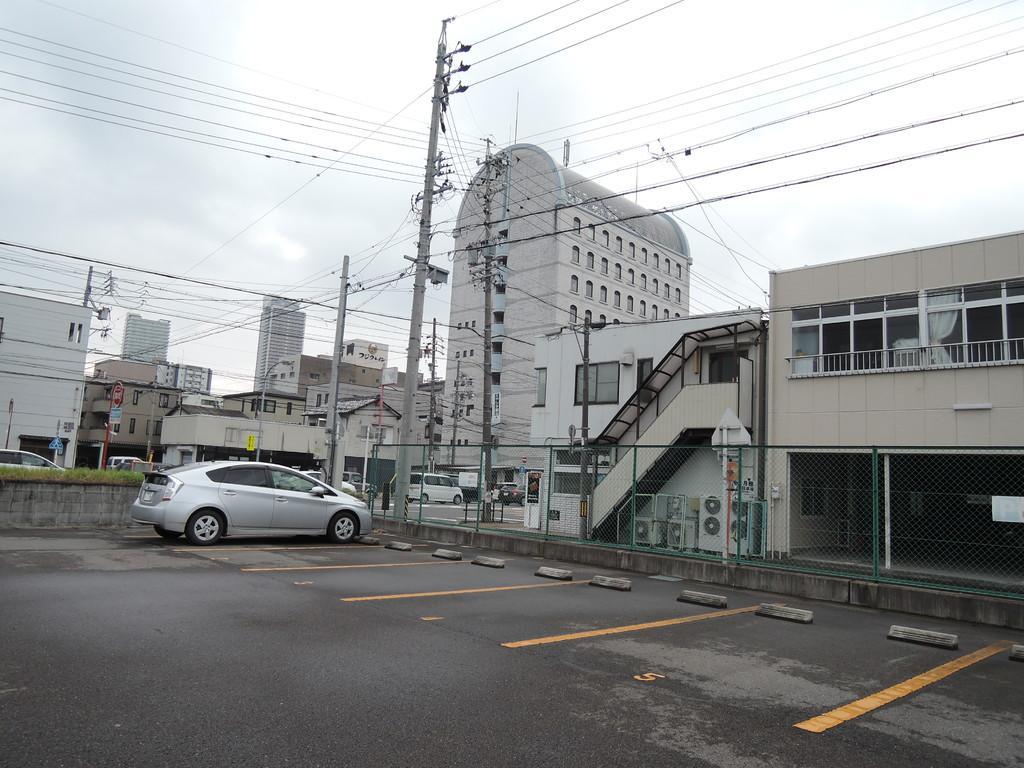How would you summarize this image in a sentence or two? In this image here there is a car. On the road few cars are moving. In the background there are buildings, electric poles. The sky is clear. These are electric wires. This is looking like a parking lot. 